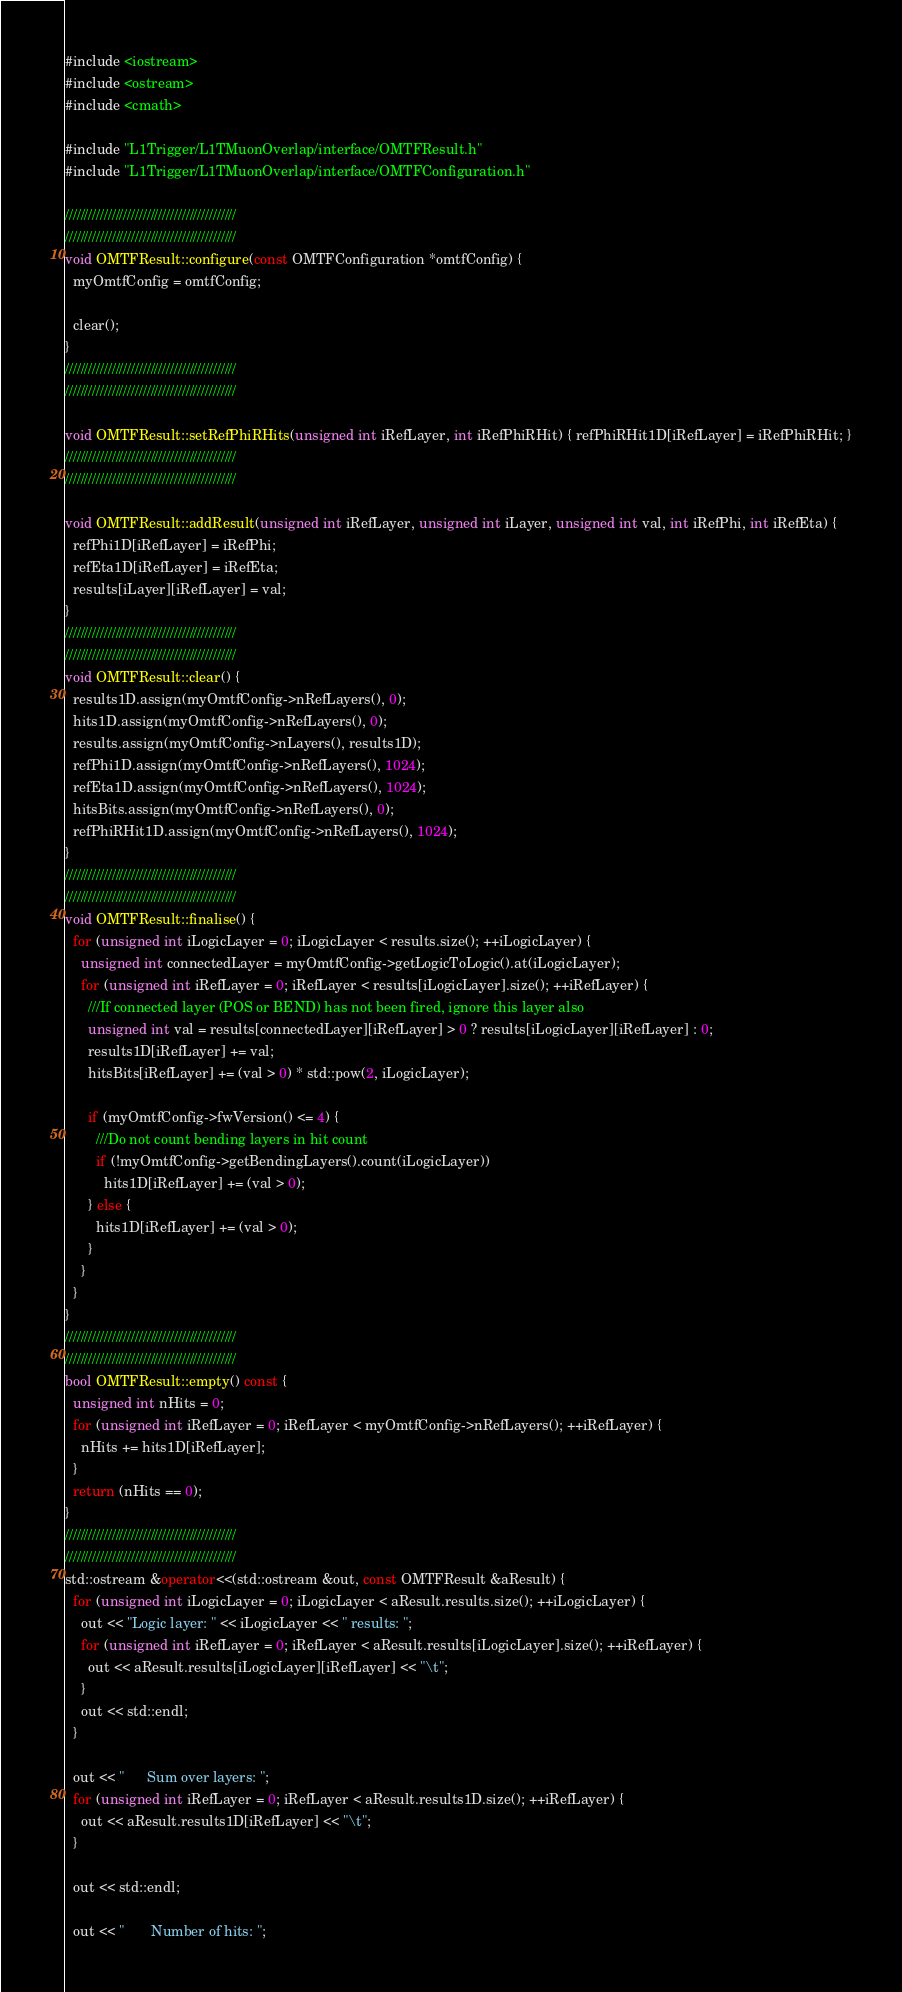Convert code to text. <code><loc_0><loc_0><loc_500><loc_500><_C++_>#include <iostream>
#include <ostream>
#include <cmath>

#include "L1Trigger/L1TMuonOverlap/interface/OMTFResult.h"
#include "L1Trigger/L1TMuonOverlap/interface/OMTFConfiguration.h"

////////////////////////////////////////////
////////////////////////////////////////////
void OMTFResult::configure(const OMTFConfiguration *omtfConfig) {
  myOmtfConfig = omtfConfig;

  clear();
}
////////////////////////////////////////////
////////////////////////////////////////////

void OMTFResult::setRefPhiRHits(unsigned int iRefLayer, int iRefPhiRHit) { refPhiRHit1D[iRefLayer] = iRefPhiRHit; }
////////////////////////////////////////////
////////////////////////////////////////////

void OMTFResult::addResult(unsigned int iRefLayer, unsigned int iLayer, unsigned int val, int iRefPhi, int iRefEta) {
  refPhi1D[iRefLayer] = iRefPhi;
  refEta1D[iRefLayer] = iRefEta;
  results[iLayer][iRefLayer] = val;
}
////////////////////////////////////////////
////////////////////////////////////////////
void OMTFResult::clear() {
  results1D.assign(myOmtfConfig->nRefLayers(), 0);
  hits1D.assign(myOmtfConfig->nRefLayers(), 0);
  results.assign(myOmtfConfig->nLayers(), results1D);
  refPhi1D.assign(myOmtfConfig->nRefLayers(), 1024);
  refEta1D.assign(myOmtfConfig->nRefLayers(), 1024);
  hitsBits.assign(myOmtfConfig->nRefLayers(), 0);
  refPhiRHit1D.assign(myOmtfConfig->nRefLayers(), 1024);
}
////////////////////////////////////////////
////////////////////////////////////////////
void OMTFResult::finalise() {
  for (unsigned int iLogicLayer = 0; iLogicLayer < results.size(); ++iLogicLayer) {
    unsigned int connectedLayer = myOmtfConfig->getLogicToLogic().at(iLogicLayer);
    for (unsigned int iRefLayer = 0; iRefLayer < results[iLogicLayer].size(); ++iRefLayer) {
      ///If connected layer (POS or BEND) has not been fired, ignore this layer also
      unsigned int val = results[connectedLayer][iRefLayer] > 0 ? results[iLogicLayer][iRefLayer] : 0;
      results1D[iRefLayer] += val;
      hitsBits[iRefLayer] += (val > 0) * std::pow(2, iLogicLayer);

      if (myOmtfConfig->fwVersion() <= 4) {
        ///Do not count bending layers in hit count
        if (!myOmtfConfig->getBendingLayers().count(iLogicLayer))
          hits1D[iRefLayer] += (val > 0);
      } else {
        hits1D[iRefLayer] += (val > 0);
      }
    }
  }
}
////////////////////////////////////////////
////////////////////////////////////////////
bool OMTFResult::empty() const {
  unsigned int nHits = 0;
  for (unsigned int iRefLayer = 0; iRefLayer < myOmtfConfig->nRefLayers(); ++iRefLayer) {
    nHits += hits1D[iRefLayer];
  }
  return (nHits == 0);
}
////////////////////////////////////////////
////////////////////////////////////////////
std::ostream &operator<<(std::ostream &out, const OMTFResult &aResult) {
  for (unsigned int iLogicLayer = 0; iLogicLayer < aResult.results.size(); ++iLogicLayer) {
    out << "Logic layer: " << iLogicLayer << " results: ";
    for (unsigned int iRefLayer = 0; iRefLayer < aResult.results[iLogicLayer].size(); ++iRefLayer) {
      out << aResult.results[iLogicLayer][iRefLayer] << "\t";
    }
    out << std::endl;
  }

  out << "      Sum over layers: ";
  for (unsigned int iRefLayer = 0; iRefLayer < aResult.results1D.size(); ++iRefLayer) {
    out << aResult.results1D[iRefLayer] << "\t";
  }

  out << std::endl;

  out << "       Number of hits: ";</code> 